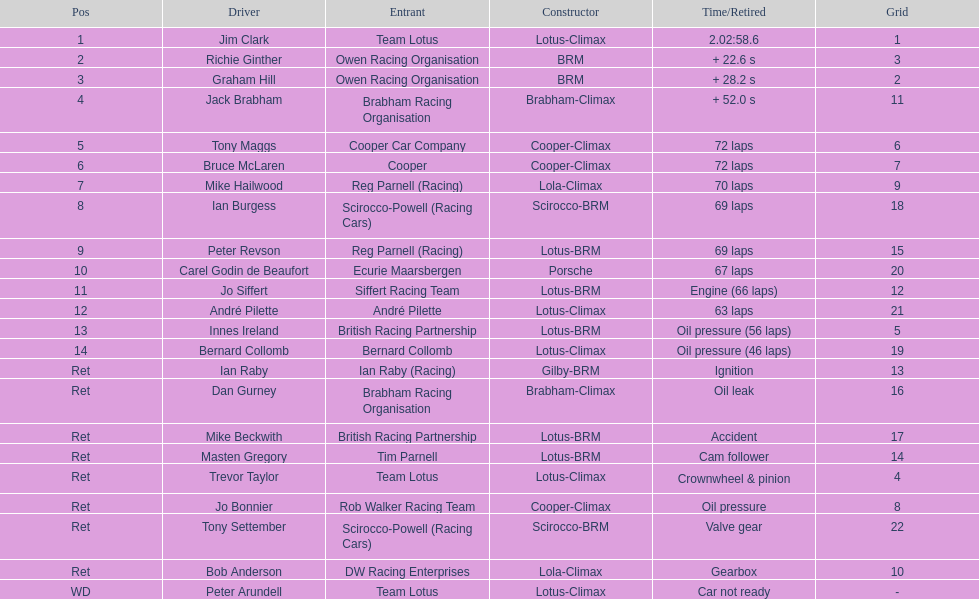In comparing germany and the uk, which had the smallest number of drivers? Germany. Help me parse the entirety of this table. {'header': ['Pos', 'Driver', 'Entrant', 'Constructor', 'Time/Retired', 'Grid'], 'rows': [['1', 'Jim Clark', 'Team Lotus', 'Lotus-Climax', '2.02:58.6', '1'], ['2', 'Richie Ginther', 'Owen Racing Organisation', 'BRM', '+ 22.6 s', '3'], ['3', 'Graham Hill', 'Owen Racing Organisation', 'BRM', '+ 28.2 s', '2'], ['4', 'Jack Brabham', 'Brabham Racing Organisation', 'Brabham-Climax', '+ 52.0 s', '11'], ['5', 'Tony Maggs', 'Cooper Car Company', 'Cooper-Climax', '72 laps', '6'], ['6', 'Bruce McLaren', 'Cooper', 'Cooper-Climax', '72 laps', '7'], ['7', 'Mike Hailwood', 'Reg Parnell (Racing)', 'Lola-Climax', '70 laps', '9'], ['8', 'Ian Burgess', 'Scirocco-Powell (Racing Cars)', 'Scirocco-BRM', '69 laps', '18'], ['9', 'Peter Revson', 'Reg Parnell (Racing)', 'Lotus-BRM', '69 laps', '15'], ['10', 'Carel Godin de Beaufort', 'Ecurie Maarsbergen', 'Porsche', '67 laps', '20'], ['11', 'Jo Siffert', 'Siffert Racing Team', 'Lotus-BRM', 'Engine (66 laps)', '12'], ['12', 'André Pilette', 'André Pilette', 'Lotus-Climax', '63 laps', '21'], ['13', 'Innes Ireland', 'British Racing Partnership', 'Lotus-BRM', 'Oil pressure (56 laps)', '5'], ['14', 'Bernard Collomb', 'Bernard Collomb', 'Lotus-Climax', 'Oil pressure (46 laps)', '19'], ['Ret', 'Ian Raby', 'Ian Raby (Racing)', 'Gilby-BRM', 'Ignition', '13'], ['Ret', 'Dan Gurney', 'Brabham Racing Organisation', 'Brabham-Climax', 'Oil leak', '16'], ['Ret', 'Mike Beckwith', 'British Racing Partnership', 'Lotus-BRM', 'Accident', '17'], ['Ret', 'Masten Gregory', 'Tim Parnell', 'Lotus-BRM', 'Cam follower', '14'], ['Ret', 'Trevor Taylor', 'Team Lotus', 'Lotus-Climax', 'Crownwheel & pinion', '4'], ['Ret', 'Jo Bonnier', 'Rob Walker Racing Team', 'Cooper-Climax', 'Oil pressure', '8'], ['Ret', 'Tony Settember', 'Scirocco-Powell (Racing Cars)', 'Scirocco-BRM', 'Valve gear', '22'], ['Ret', 'Bob Anderson', 'DW Racing Enterprises', 'Lola-Climax', 'Gearbox', '10'], ['WD', 'Peter Arundell', 'Team Lotus', 'Lotus-Climax', 'Car not ready', '-']]} 